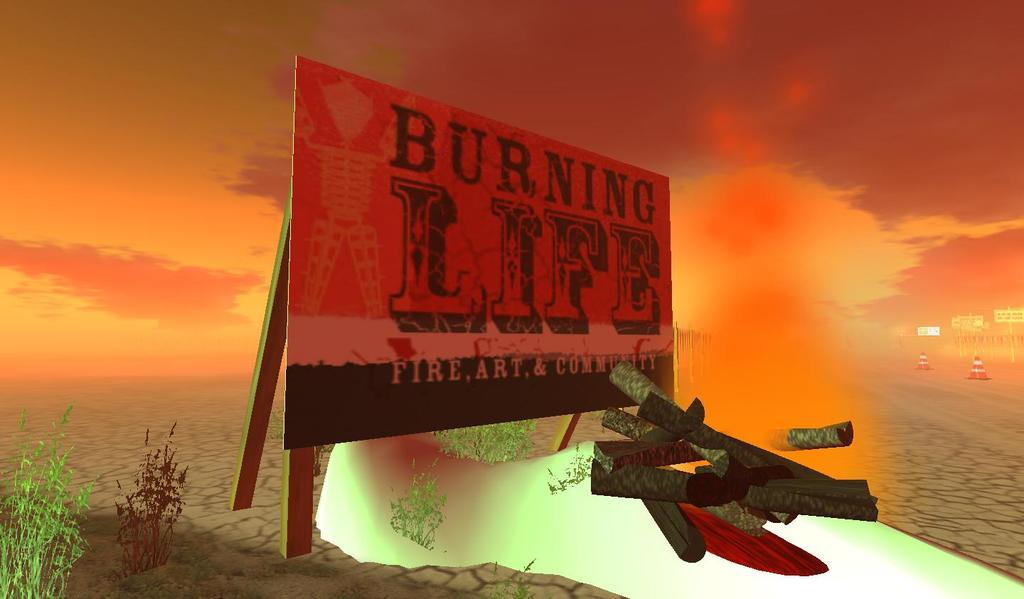<image>
Give a short and clear explanation of the subsequent image. A sign says burning life in front of an orange sunset. 